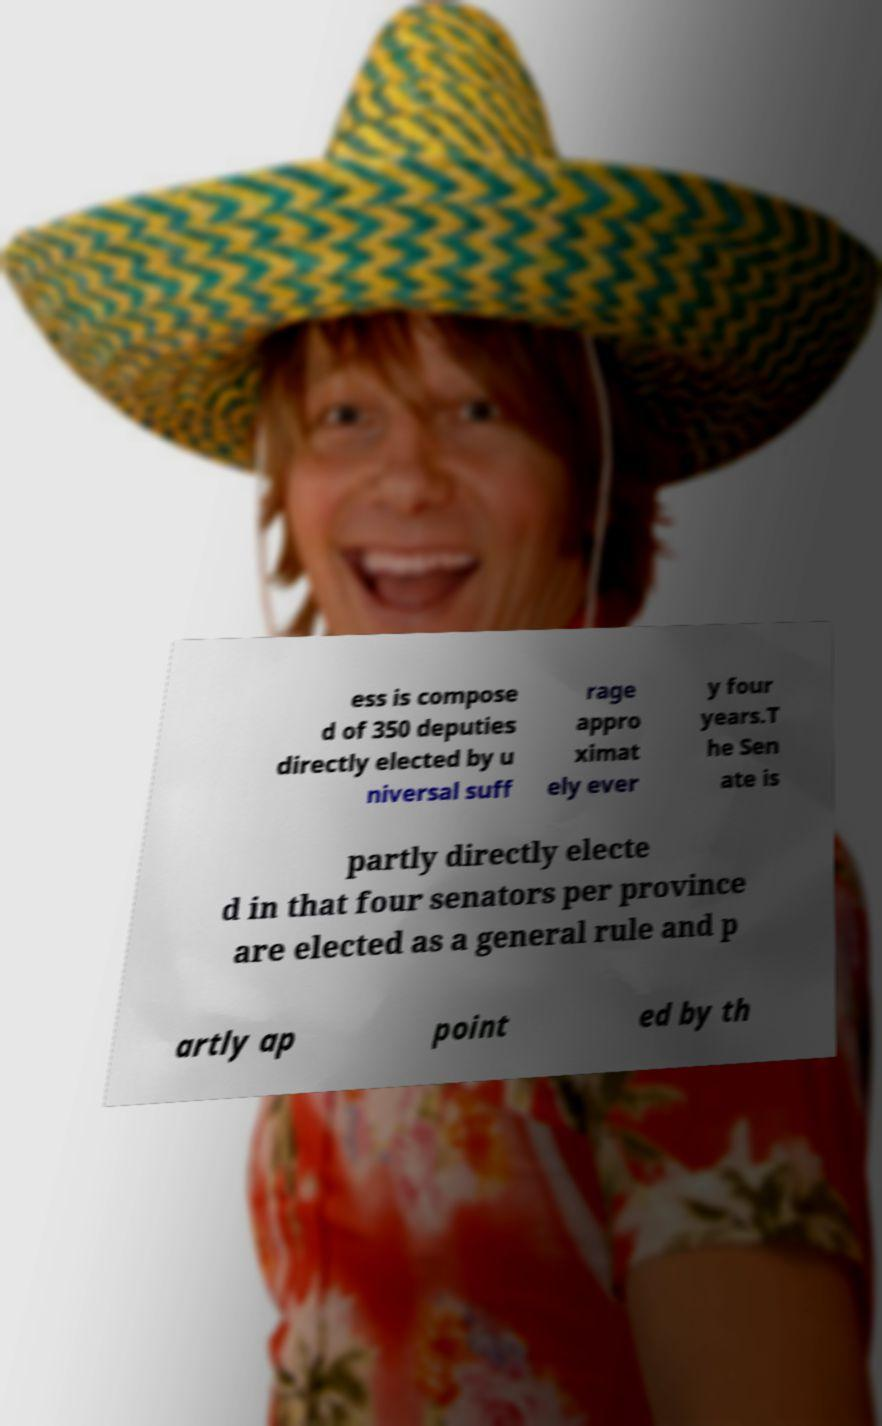I need the written content from this picture converted into text. Can you do that? ess is compose d of 350 deputies directly elected by u niversal suff rage appro ximat ely ever y four years.T he Sen ate is partly directly electe d in that four senators per province are elected as a general rule and p artly ap point ed by th 